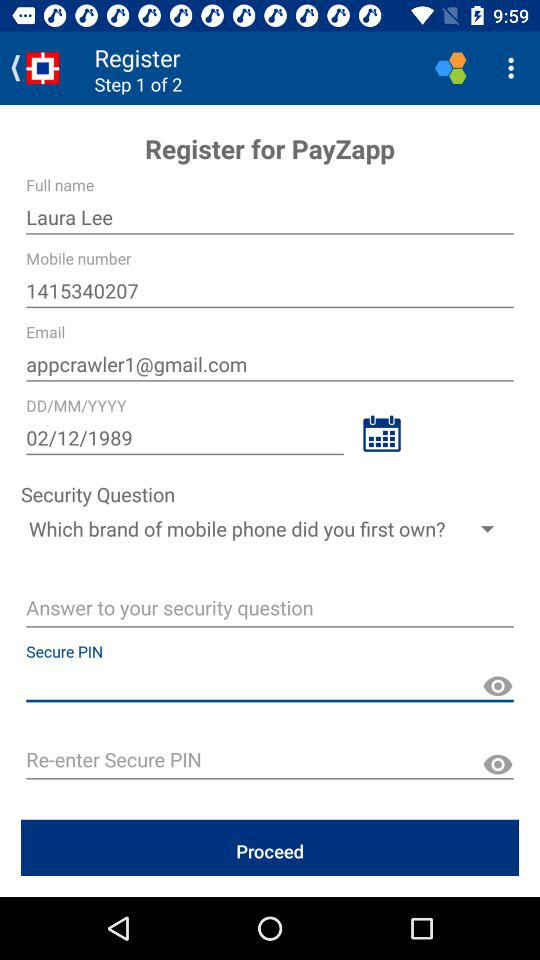What is the security question? The security question is "Which brand of mobile phone did you first own?". 